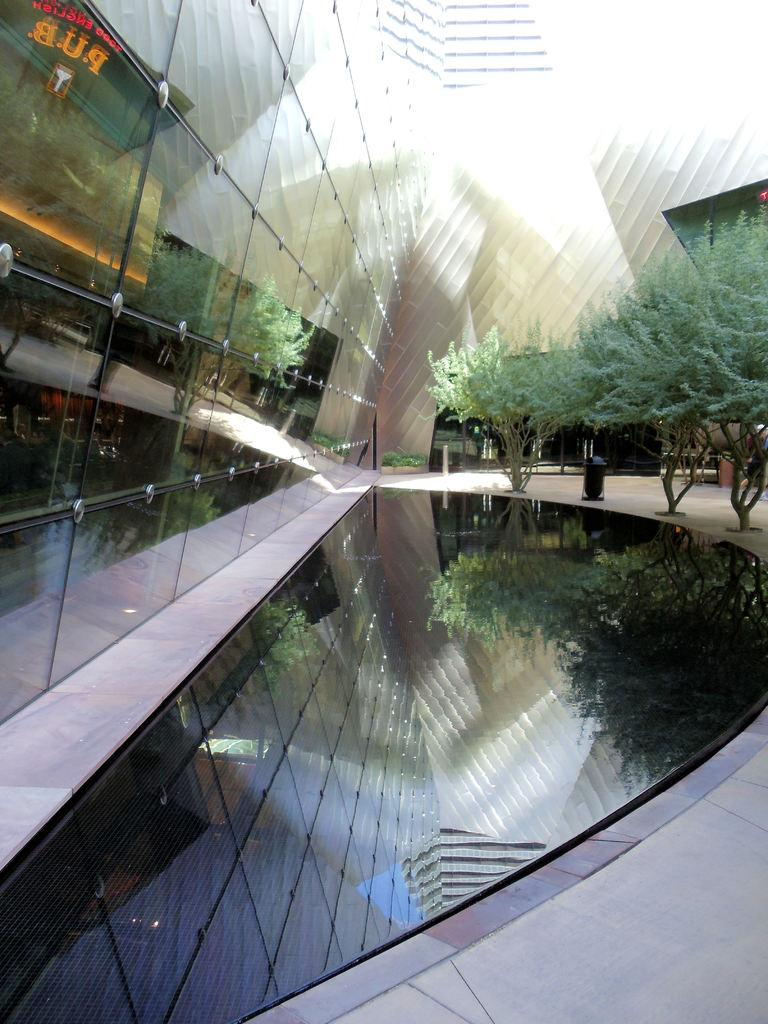What object is present in the image that is typically used for drinking? There is a glass in the image. What type of structure can be seen in the image? There is a building in the image. What type of vegetation is visible in the image? There are trees in the image. What surface is visible in the image? The floor is visible in the image. What type of yarn is being used to create the effect of a cub in the image? There is no yarn or cub present in the image. What type of effect is being created by the yarn in the image? There is no yarn or effect present in the image. 